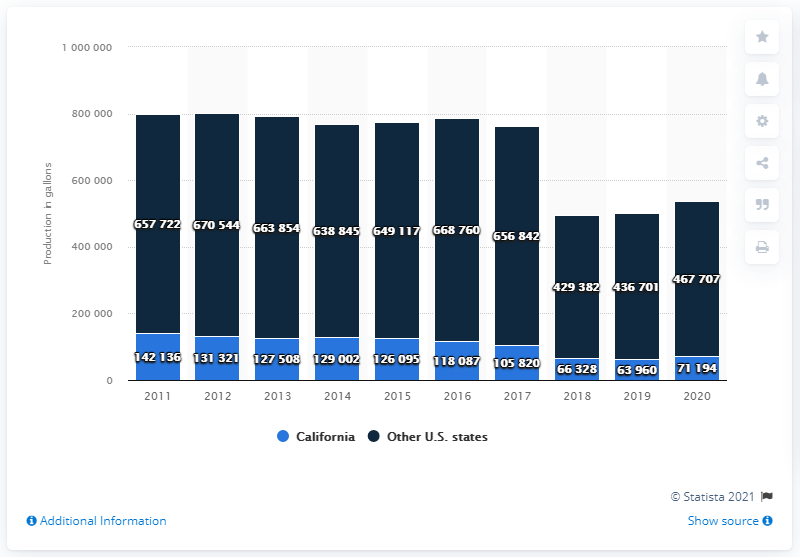Point out several critical features in this image. California produced the most ice cream in the United States in 2020. In 2020, California produced a total of 467,707 gallons of ice cream. 